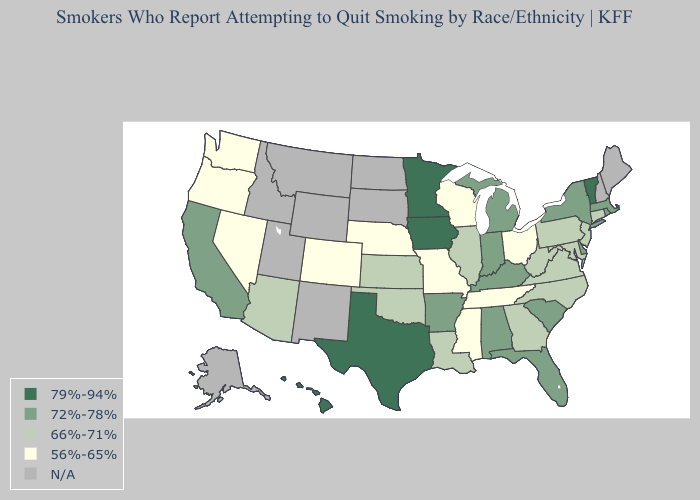Name the states that have a value in the range 72%-78%?
Be succinct. Alabama, Arkansas, California, Delaware, Florida, Indiana, Kentucky, Massachusetts, Michigan, New York, Rhode Island, South Carolina. Does Alabama have the highest value in the USA?
Short answer required. No. What is the value of Arizona?
Quick response, please. 66%-71%. Name the states that have a value in the range 56%-65%?
Give a very brief answer. Colorado, Mississippi, Missouri, Nebraska, Nevada, Ohio, Oregon, Tennessee, Washington, Wisconsin. Name the states that have a value in the range N/A?
Give a very brief answer. Alaska, Idaho, Maine, Montana, New Hampshire, New Mexico, North Dakota, South Dakota, Utah, Wyoming. What is the value of Utah?
Be succinct. N/A. What is the value of Wyoming?
Answer briefly. N/A. How many symbols are there in the legend?
Concise answer only. 5. Which states have the lowest value in the USA?
Concise answer only. Colorado, Mississippi, Missouri, Nebraska, Nevada, Ohio, Oregon, Tennessee, Washington, Wisconsin. Name the states that have a value in the range N/A?
Answer briefly. Alaska, Idaho, Maine, Montana, New Hampshire, New Mexico, North Dakota, South Dakota, Utah, Wyoming. What is the value of Alabama?
Short answer required. 72%-78%. What is the highest value in the Northeast ?
Be succinct. 79%-94%. Which states have the lowest value in the Northeast?
Answer briefly. Connecticut, New Jersey, Pennsylvania. Among the states that border New Hampshire , does Massachusetts have the highest value?
Give a very brief answer. No. 